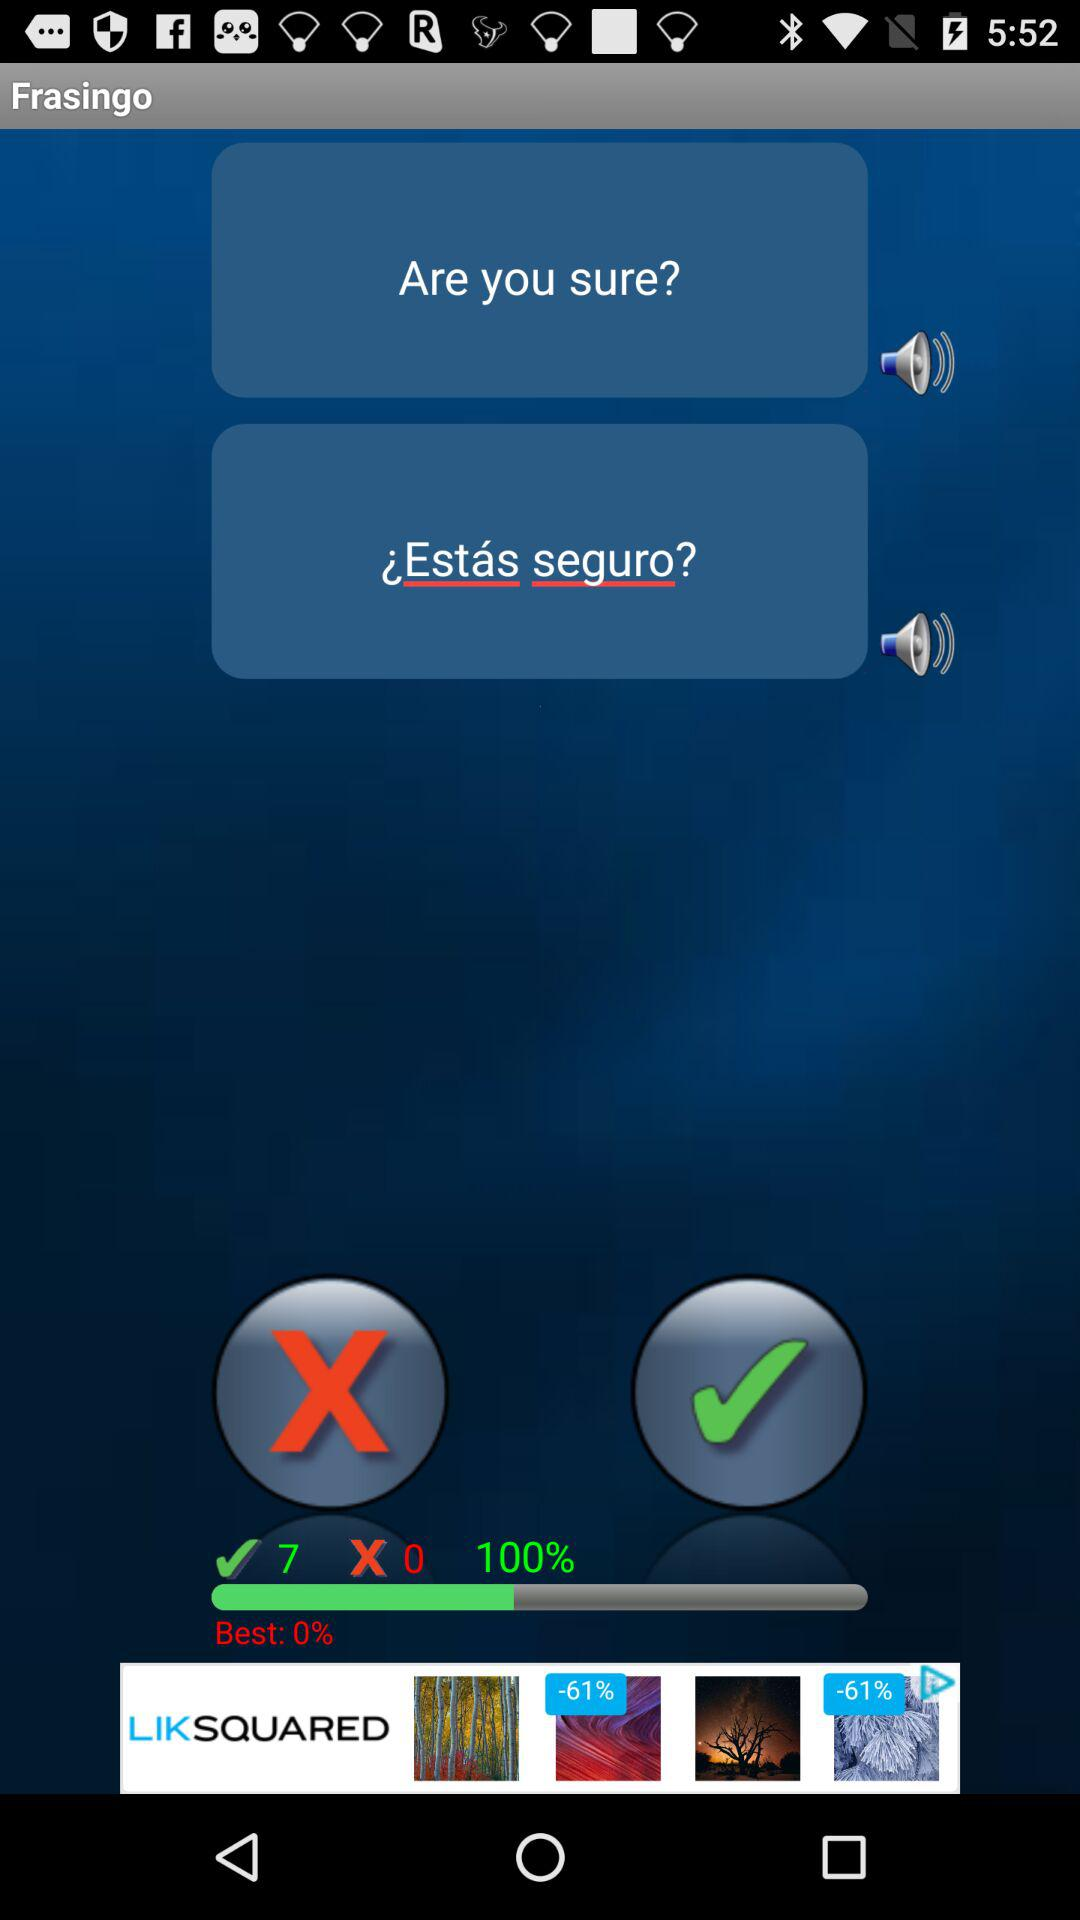What's the total number of right answers? The total number of right answers is 7. 